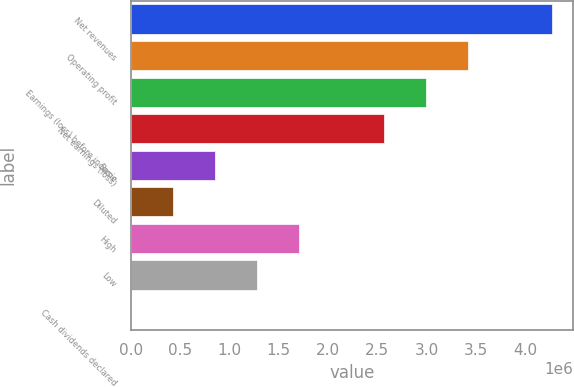<chart> <loc_0><loc_0><loc_500><loc_500><bar_chart><fcel>Net revenues<fcel>Operating profit<fcel>Earnings (loss) before income<fcel>Net earnings (loss)<fcel>Basic<fcel>Diluted<fcel>High<fcel>Low<fcel>Cash dividends declared<nl><fcel>4.27721e+06<fcel>3.42177e+06<fcel>2.99405e+06<fcel>2.56632e+06<fcel>855443<fcel>427722<fcel>1.71088e+06<fcel>1.28316e+06<fcel>1.72<nl></chart> 